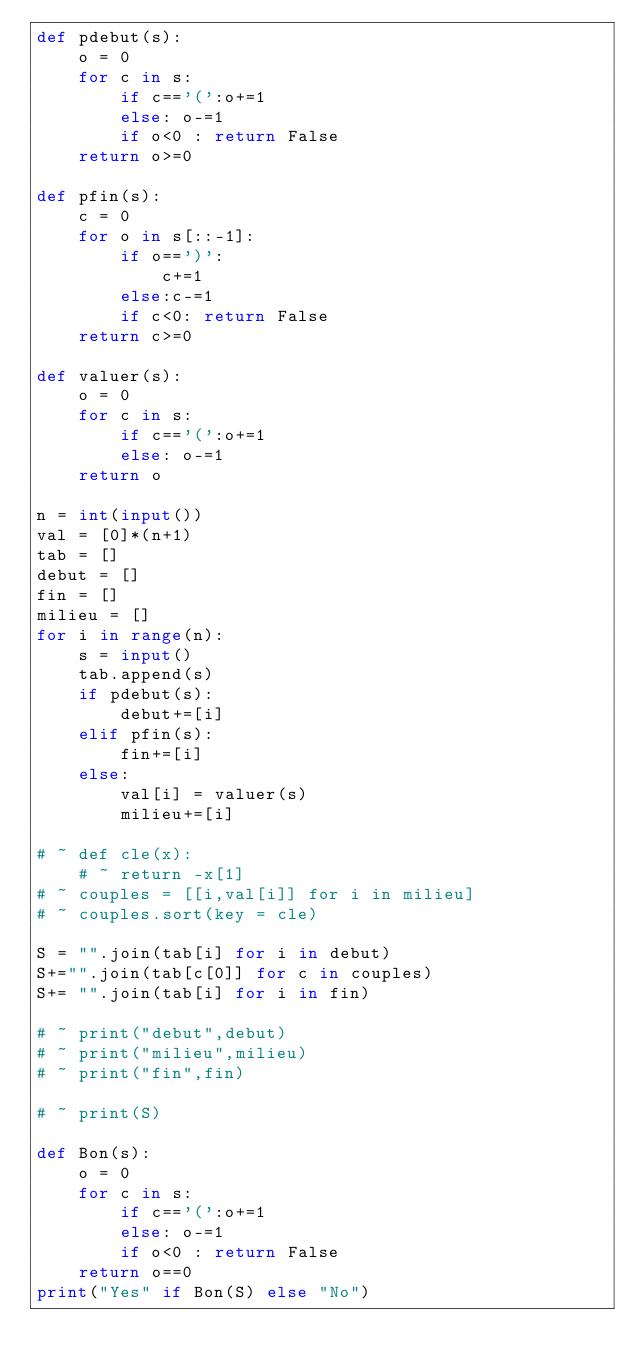Convert code to text. <code><loc_0><loc_0><loc_500><loc_500><_Python_>def pdebut(s):
	o = 0
	for c in s:
		if c=='(':o+=1
		else: o-=1
		if o<0 : return False
	return o>=0
	
def pfin(s):
	c = 0
	for o in s[::-1]:
		if o==')':
			c+=1
		else:c-=1
		if c<0: return False
	return c>=0
	
def valuer(s):
	o = 0
	for c in s:
		if c=='(':o+=1
		else: o-=1
	return o
	
n = int(input())
val = [0]*(n+1)
tab = []
debut = []
fin = []
milieu = []
for i in range(n):
	s = input()
	tab.append(s)
	if pdebut(s):
		debut+=[i]
	elif pfin(s):
		fin+=[i]
	else:
		val[i] = valuer(s)
		milieu+=[i]

# ~ def cle(x):
	# ~ return -x[1]		
# ~ couples = [[i,val[i]] for i in milieu]
# ~ couples.sort(key = cle)

S = "".join(tab[i] for i in debut)
S+="".join(tab[c[0]] for c in couples)
S+= "".join(tab[i] for i in fin)

# ~ print("debut",debut)
# ~ print("milieu",milieu)
# ~ print("fin",fin)

# ~ print(S)

def Bon(s):
	o = 0
	for c in s:
		if c=='(':o+=1
		else: o-=1
		if o<0 : return False
	return o==0
print("Yes" if Bon(S) else "No")
</code> 